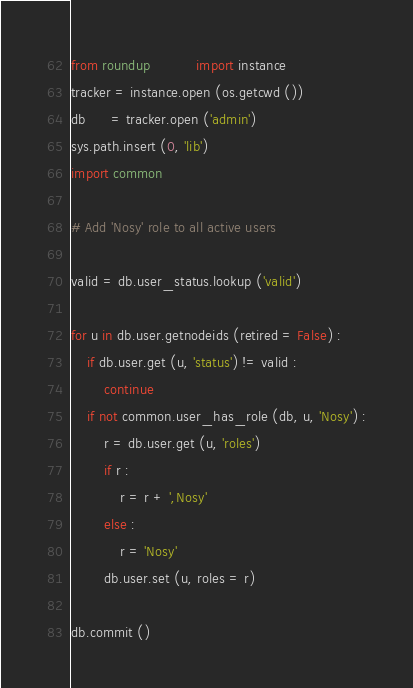<code> <loc_0><loc_0><loc_500><loc_500><_Python_>from roundup           import instance
tracker = instance.open (os.getcwd ())
db      = tracker.open ('admin')
sys.path.insert (0, 'lib')
import common

# Add 'Nosy' role to all active users

valid = db.user_status.lookup ('valid')

for u in db.user.getnodeids (retired = False) :
    if db.user.get (u, 'status') != valid :
        continue
    if not common.user_has_role (db, u, 'Nosy') :
        r = db.user.get (u, 'roles')
        if r :
            r = r + ',Nosy'
        else :
            r = 'Nosy'
        db.user.set (u, roles = r)

db.commit ()
</code> 